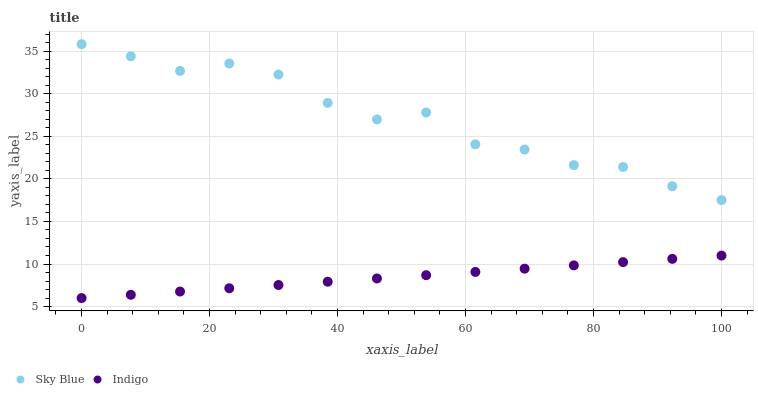Does Indigo have the minimum area under the curve?
Answer yes or no. Yes. Does Sky Blue have the maximum area under the curve?
Answer yes or no. Yes. Does Indigo have the maximum area under the curve?
Answer yes or no. No. Is Indigo the smoothest?
Answer yes or no. Yes. Is Sky Blue the roughest?
Answer yes or no. Yes. Is Indigo the roughest?
Answer yes or no. No. Does Indigo have the lowest value?
Answer yes or no. Yes. Does Sky Blue have the highest value?
Answer yes or no. Yes. Does Indigo have the highest value?
Answer yes or no. No. Is Indigo less than Sky Blue?
Answer yes or no. Yes. Is Sky Blue greater than Indigo?
Answer yes or no. Yes. Does Indigo intersect Sky Blue?
Answer yes or no. No. 